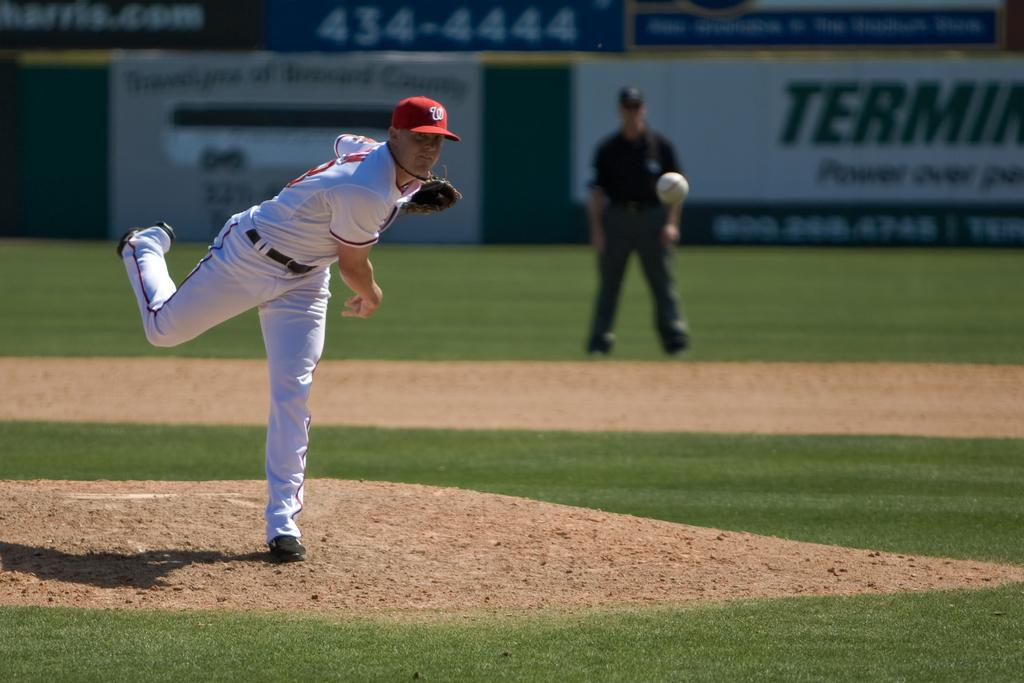Provide a one-sentence caption for the provided image. A pitcher with a W on his hat leans forward as he finishes his pitch. 